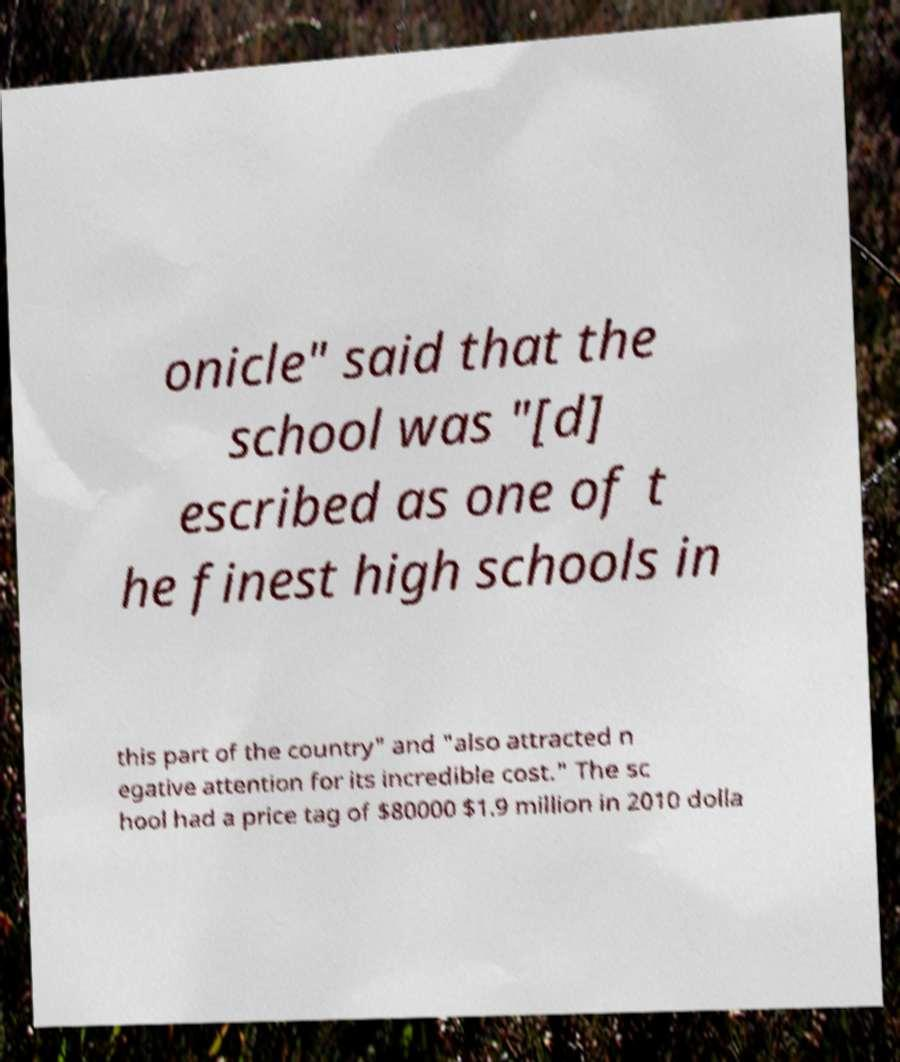There's text embedded in this image that I need extracted. Can you transcribe it verbatim? onicle" said that the school was "[d] escribed as one of t he finest high schools in this part of the country" and "also attracted n egative attention for its incredible cost." The sc hool had a price tag of $80000 $1.9 million in 2010 dolla 